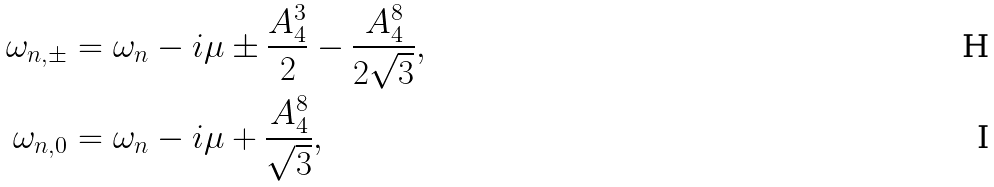Convert formula to latex. <formula><loc_0><loc_0><loc_500><loc_500>\omega _ { n , \pm } & = \omega _ { n } - i \mu \pm \frac { A _ { 4 } ^ { 3 } } { 2 } - \frac { A _ { 4 } ^ { 8 } } { 2 \sqrt { 3 } } , \\ \omega _ { n , 0 } & = \omega _ { n } - i \mu + \frac { A _ { 4 } ^ { 8 } } { \sqrt { 3 } } ,</formula> 